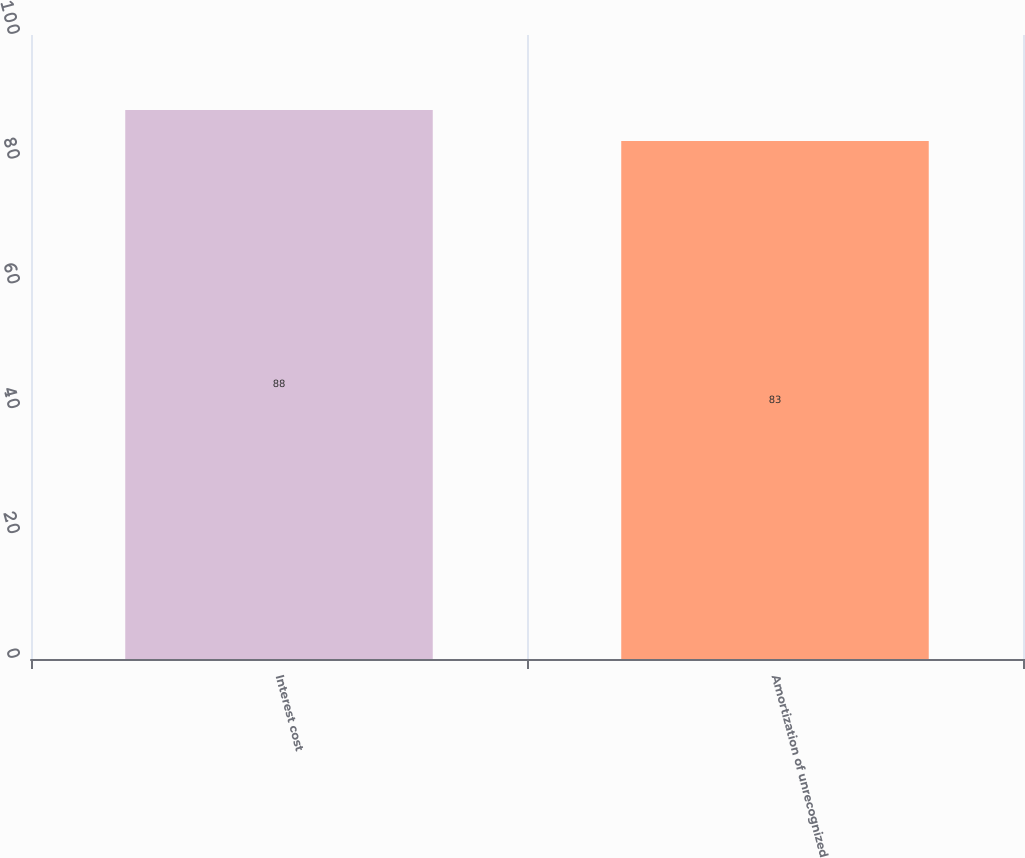Convert chart. <chart><loc_0><loc_0><loc_500><loc_500><bar_chart><fcel>Interest cost<fcel>Amortization of unrecognized<nl><fcel>88<fcel>83<nl></chart> 